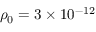Convert formula to latex. <formula><loc_0><loc_0><loc_500><loc_500>\rho _ { 0 } = 3 \times 1 0 ^ { - 1 2 }</formula> 